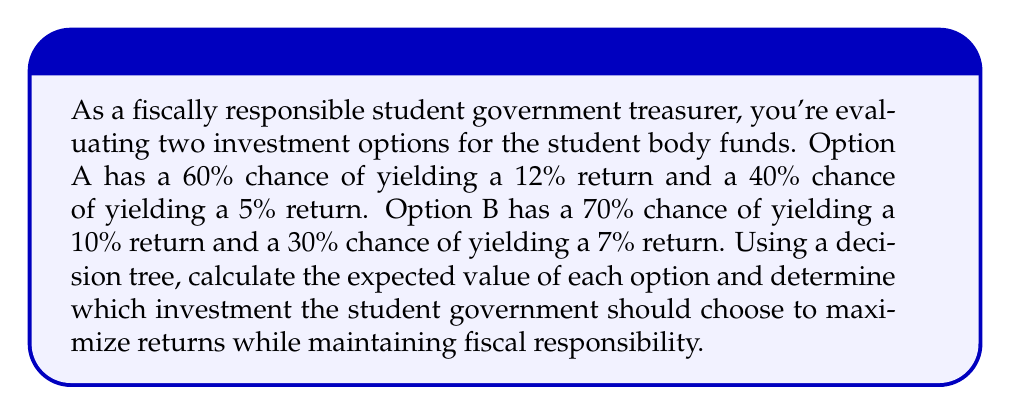Solve this math problem. To solve this problem, we'll use a decision tree to calculate the expected value of each investment option. The expected value is the sum of each possible outcome multiplied by its probability.

1. Create a decision tree:

[asy]
import geometry;

pair A = (0,0), B = (100,50), C = (100,-50);
pair D = (200,75), E = (200,25), F = (200,-25), G = (200,-75);

draw(A--B--D);
draw(B--E);
draw(A--C--F);
draw(C--G);

label("Option A", (50,50), N);
label("Option B", (50,-50), S);
label("60%", (150,62.5), N);
label("40%", (150,37.5), S);
label("70%", (150,-37.5), N);
label("30%", (150,-62.5), S);
label("12%", (210,75), E);
label("5%", (210,25), E);
label("10%", (210,-25), E);
label("7%", (210,-75), E);

dot(A);
dot(B);
dot(C);
dot(D);
dot(E);
dot(F);
dot(G);
[/asy]

2. Calculate the expected value for Option A:
   $EV_A = (0.60 \times 0.12) + (0.40 \times 0.05)$
   $EV_A = 0.072 + 0.02 = 0.092$ or 9.2%

3. Calculate the expected value for Option B:
   $EV_B = (0.70 \times 0.10) + (0.30 \times 0.07)$
   $EV_B = 0.07 + 0.021 = 0.091$ or 9.1%

4. Compare the expected values:
   Option A has a higher expected value (9.2%) compared to Option B (9.1%).

5. Consider risk:
   While Option A has a slightly higher expected value, it also has a wider range of possible outcomes (5% to 12%) compared to Option B (7% to 10%). This indicates that Option A is slightly riskier.

6. Make a decision:
   As a fiscally responsible treasurer, you should consider both the expected return and the risk. In this case, the difference in expected return is minimal (0.1%), but Option B offers a more consistent return with less risk.
Answer: The student government should choose Option B. While it has a slightly lower expected return (9.1% vs 9.2%), it offers a more consistent and less risky investment, which aligns better with the goal of fiscal responsibility. 